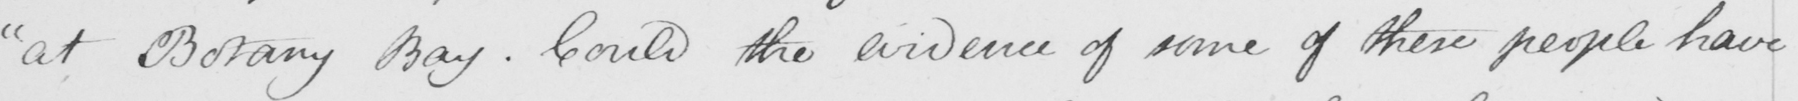Please provide the text content of this handwritten line. " at Botany Bay . Could the evidence of some of these people have 